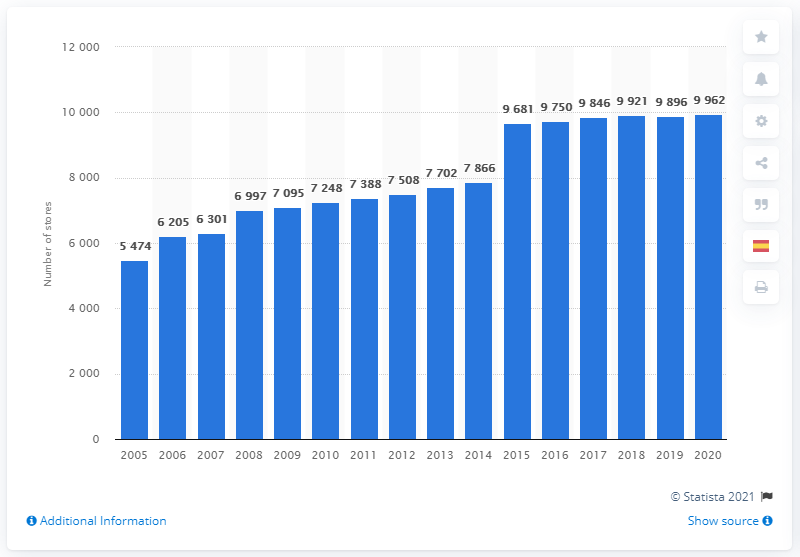Point out several critical features in this image. As of 2020, CVS Health had a total of 9,962 stores. In 2014, CVS changed its name from CVS Caremark to CVS Health. 